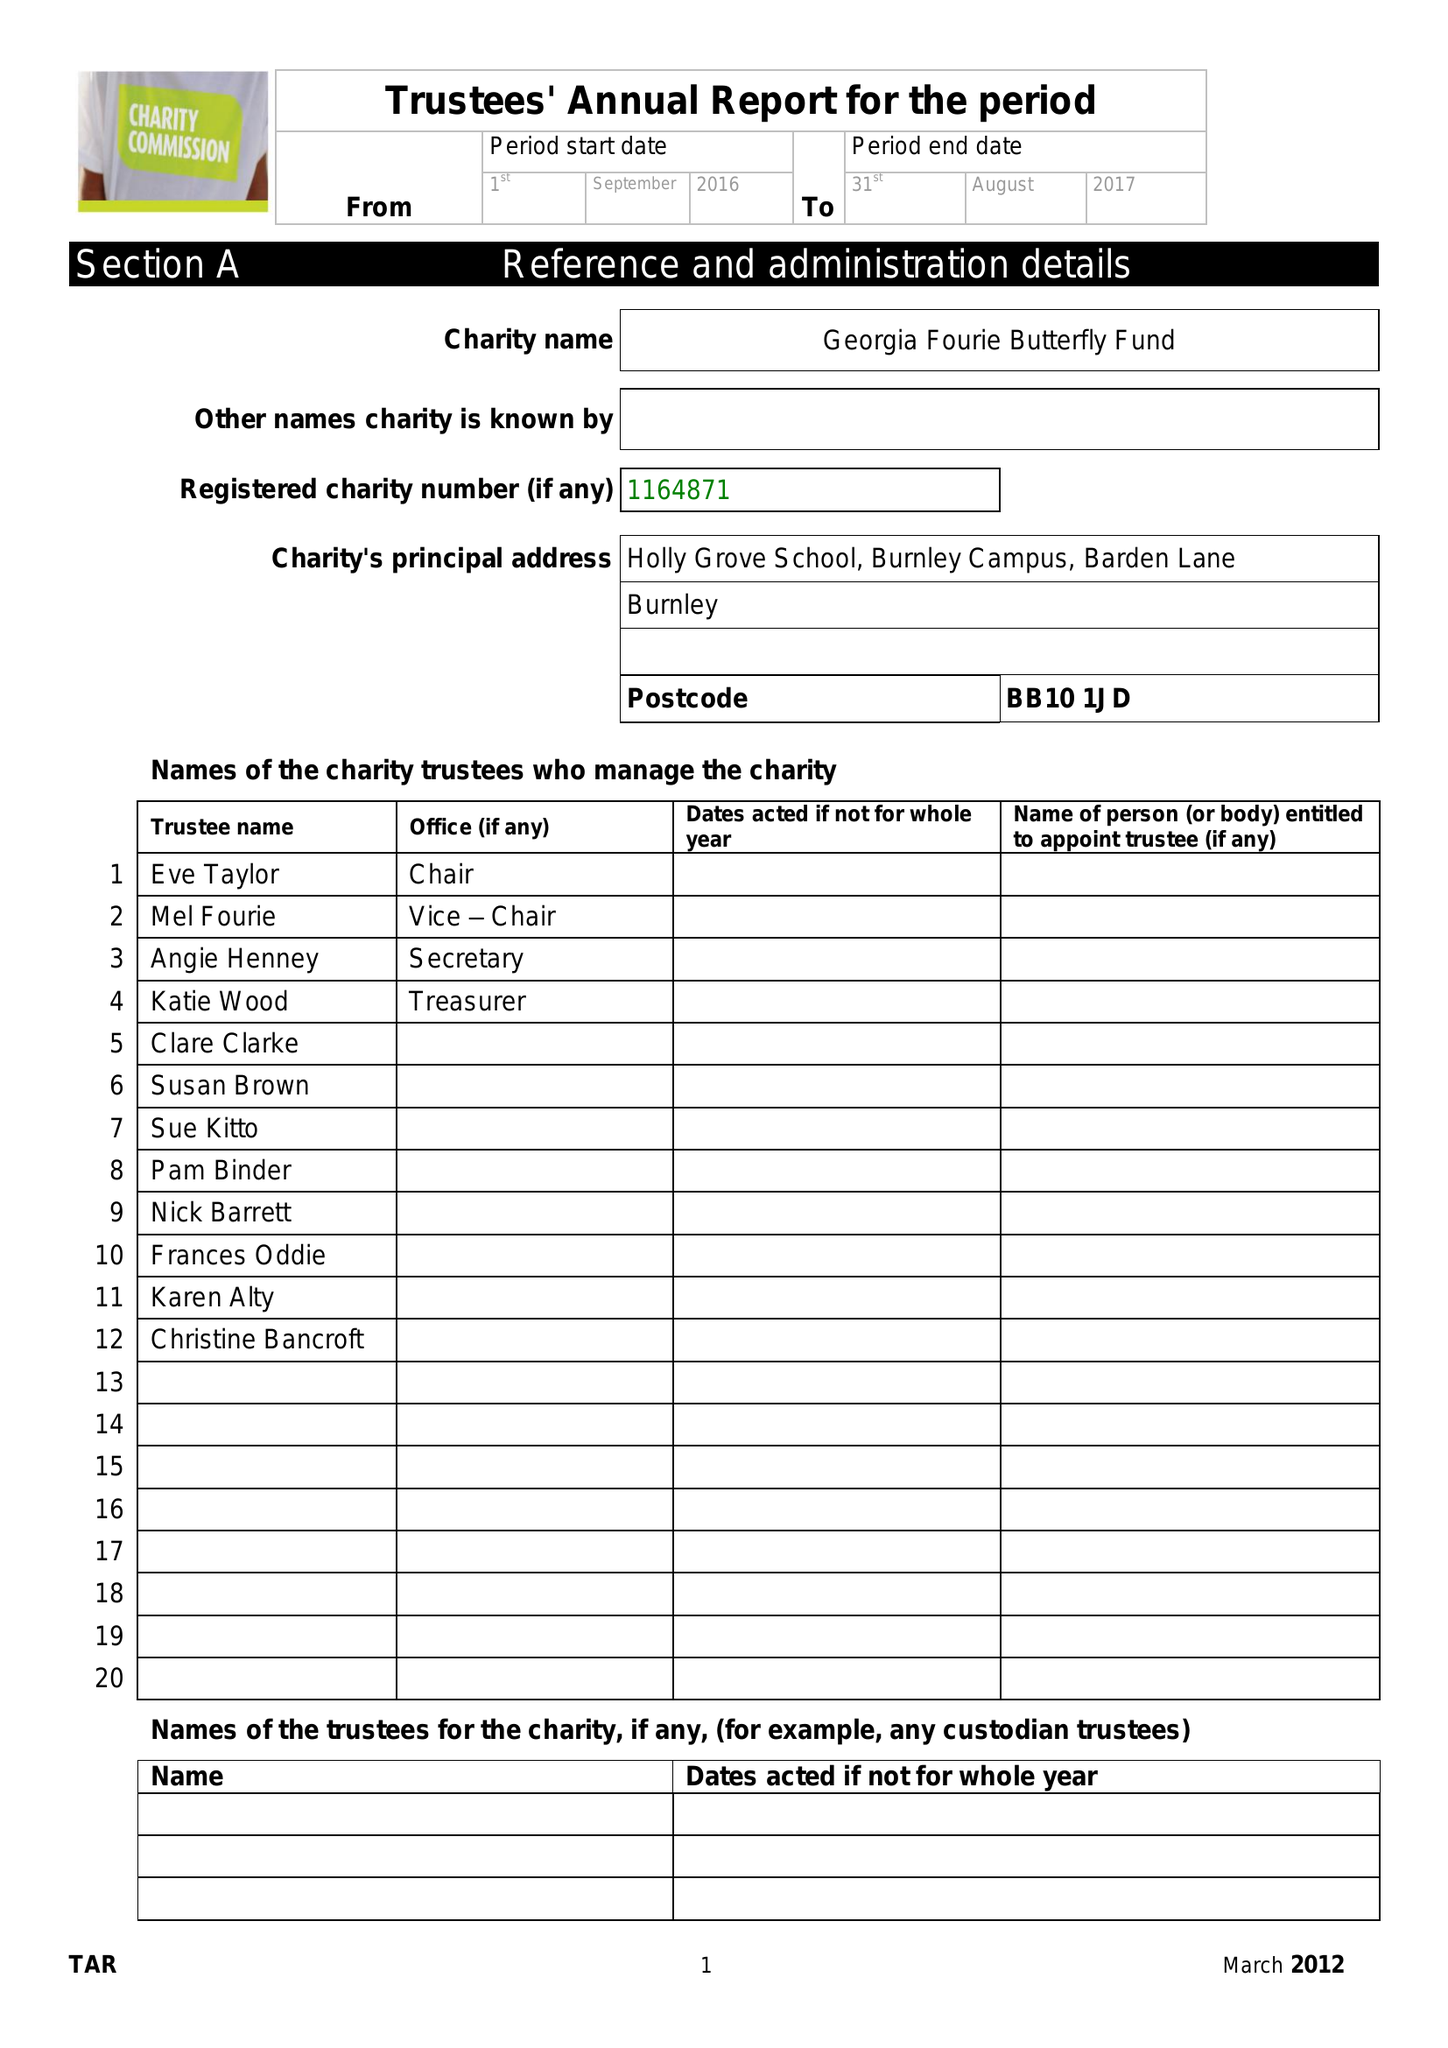What is the value for the income_annually_in_british_pounds?
Answer the question using a single word or phrase. 9817.00 